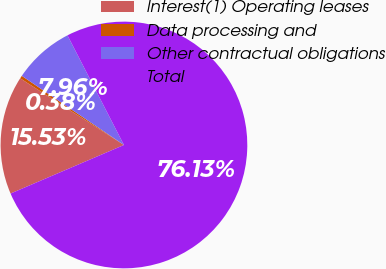<chart> <loc_0><loc_0><loc_500><loc_500><pie_chart><fcel>Interest(1) Operating leases<fcel>Data processing and<fcel>Other contractual obligations<fcel>Total<nl><fcel>15.53%<fcel>0.38%<fcel>7.96%<fcel>76.13%<nl></chart> 